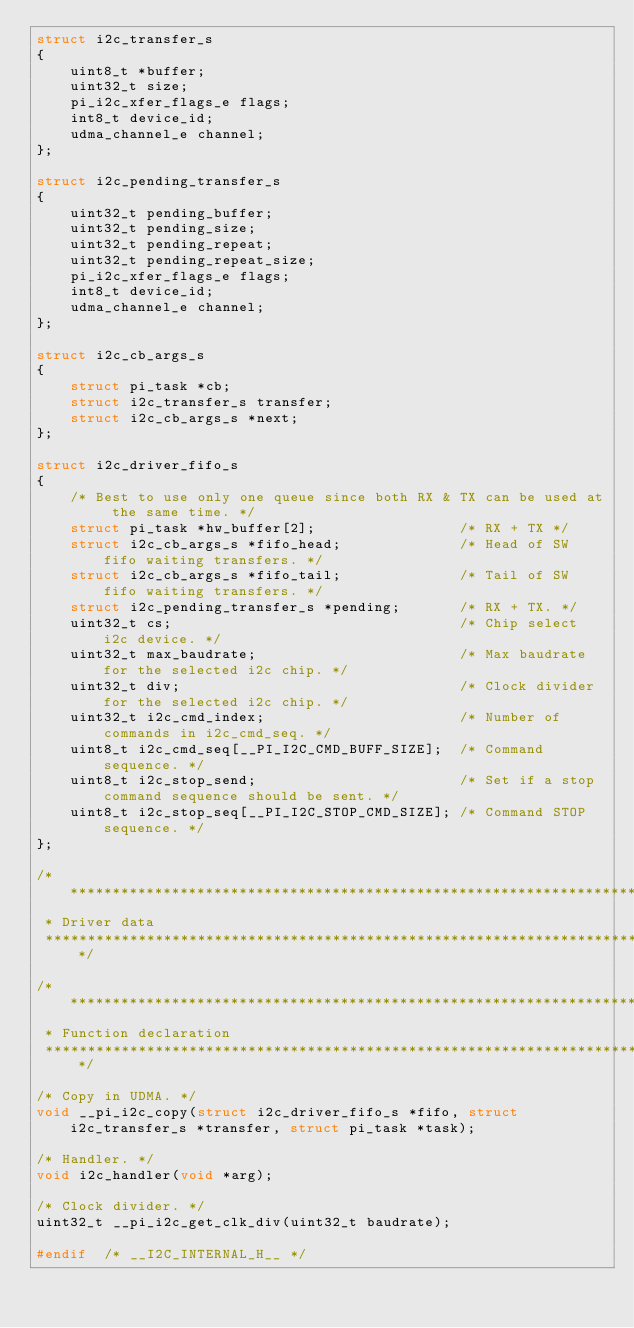<code> <loc_0><loc_0><loc_500><loc_500><_C_>struct i2c_transfer_s
{
    uint8_t *buffer;
    uint32_t size;
    pi_i2c_xfer_flags_e flags;
    int8_t device_id;
    udma_channel_e channel;
};

struct i2c_pending_transfer_s
{
    uint32_t pending_buffer;
    uint32_t pending_size;
    uint32_t pending_repeat;
    uint32_t pending_repeat_size;
    pi_i2c_xfer_flags_e flags;
    int8_t device_id;
    udma_channel_e channel;
};

struct i2c_cb_args_s
{
    struct pi_task *cb;
    struct i2c_transfer_s transfer;
    struct i2c_cb_args_s *next;
};

struct i2c_driver_fifo_s
{
    /* Best to use only one queue since both RX & TX can be used at the same time. */
    struct pi_task *hw_buffer[2];                 /* RX + TX */
    struct i2c_cb_args_s *fifo_head;              /* Head of SW fifo waiting transfers. */
    struct i2c_cb_args_s *fifo_tail;              /* Tail of SW fifo waiting transfers. */
    struct i2c_pending_transfer_s *pending;       /* RX + TX. */
    uint32_t cs;                                  /* Chip select i2c device. */
    uint32_t max_baudrate;                        /* Max baudrate for the selected i2c chip. */
    uint32_t div;                                 /* Clock divider for the selected i2c chip. */
    uint32_t i2c_cmd_index;                       /* Number of commands in i2c_cmd_seq. */
    uint8_t i2c_cmd_seq[__PI_I2C_CMD_BUFF_SIZE];  /* Command sequence. */
    uint8_t i2c_stop_send;                        /* Set if a stop command sequence should be sent. */
    uint8_t i2c_stop_seq[__PI_I2C_STOP_CMD_SIZE]; /* Command STOP sequence. */
};

/*******************************************************************************
 * Driver data
 *****************************************************************************/

/*******************************************************************************
 * Function declaration
 ******************************************************************************/

/* Copy in UDMA. */
void __pi_i2c_copy(struct i2c_driver_fifo_s *fifo, struct i2c_transfer_s *transfer, struct pi_task *task);

/* Handler. */
void i2c_handler(void *arg);

/* Clock divider. */
uint32_t __pi_i2c_get_clk_div(uint32_t baudrate);

#endif  /* __I2C_INTERNAL_H__ */
</code> 